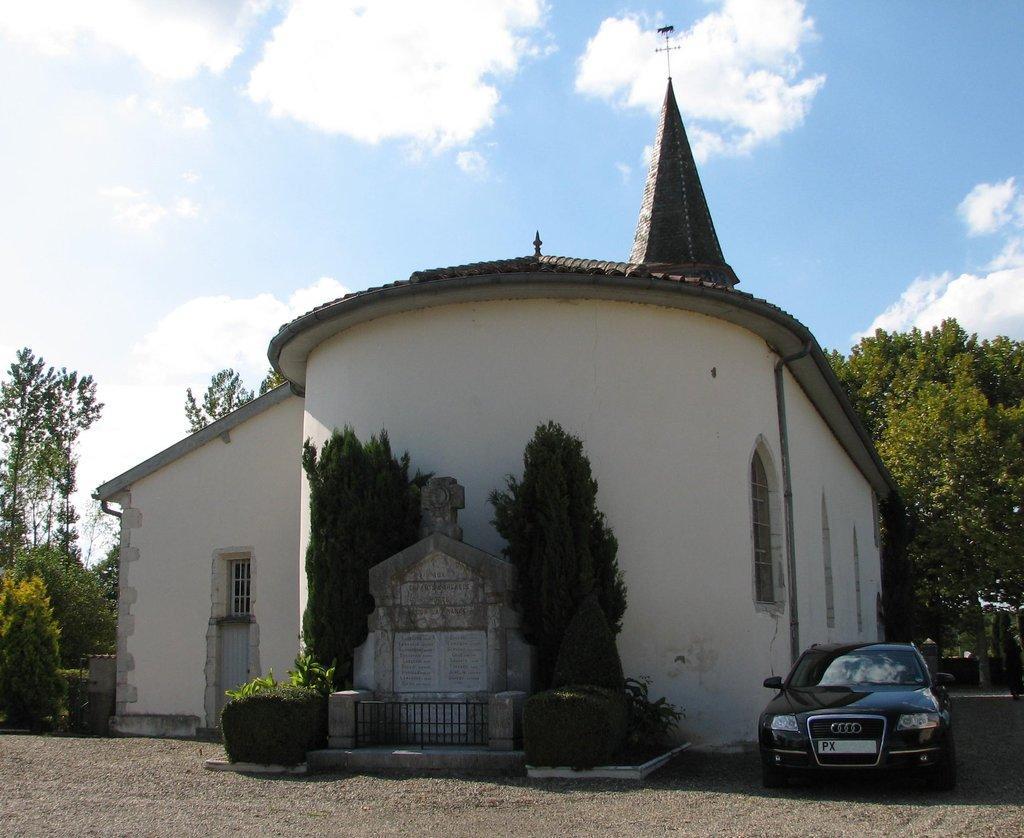Please provide a concise description of this image. In the center of the image a building is present. On the left side of the image we can see trees are there. In the middle of the image some plants, bushes are present. On the right side of the image a car is there. At the top of the image clouds are present in the sky. At the bottom of the image ground is there. 